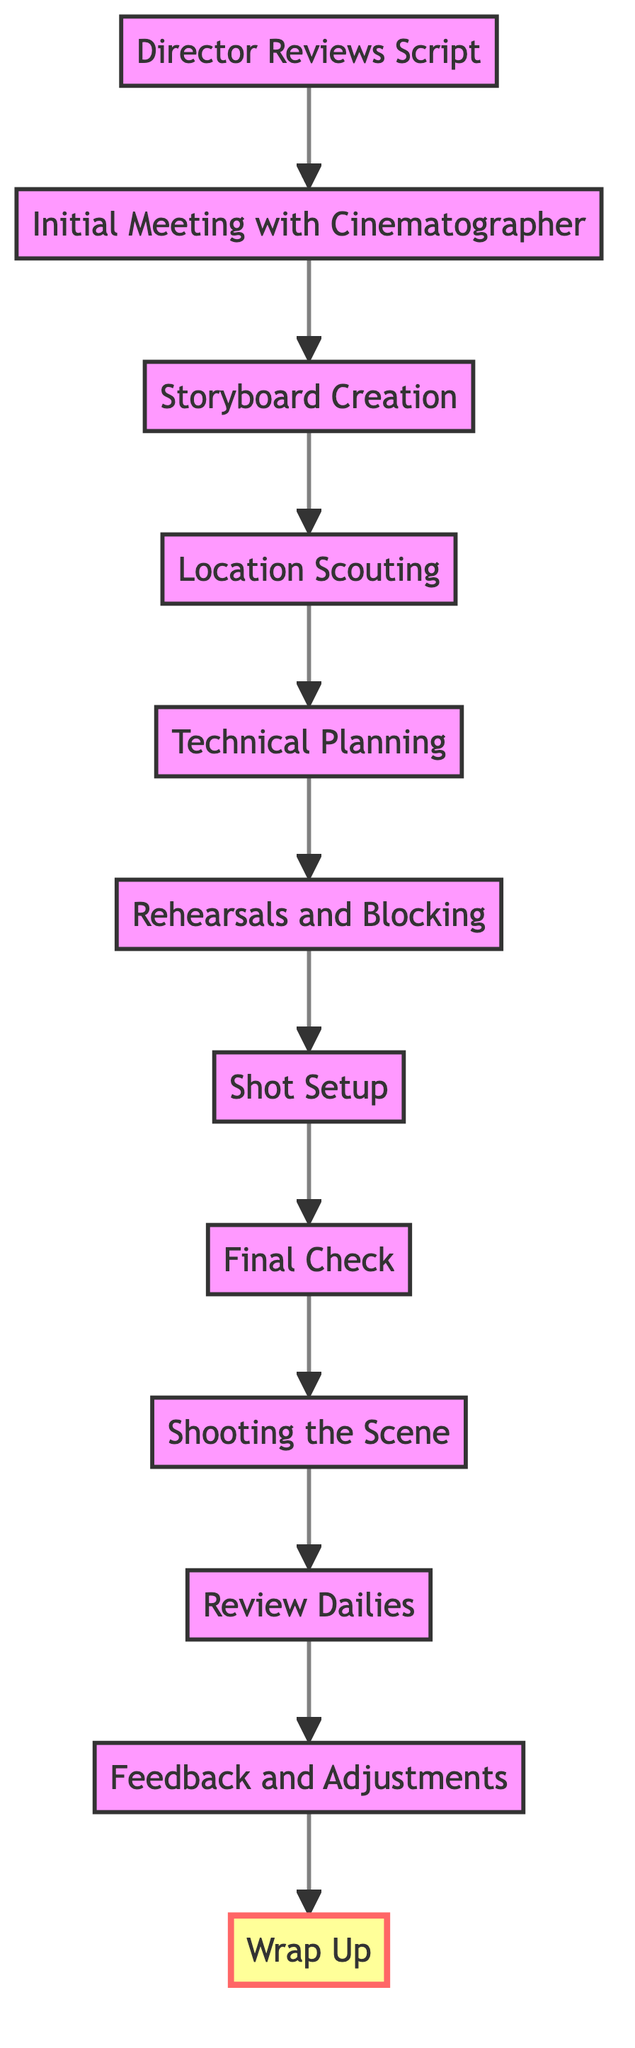What is the first step in the workflow? The first step is "Director Reviews Script," which initiates the collaboration process.
Answer: Director Reviews Script How many nodes are there in the diagram? The diagram contains 12 nodes representing different steps in the collaboration workflow.
Answer: 12 What happens after the "Initial Meeting with Cinematographer"? After "Initial Meeting with Cinematographer," the next step is "Storyboard Creation."
Answer: Storyboard Creation Which node follows "Shooting the Scene"? The node that follows "Shooting the Scene" is "Review Dailies."
Answer: Review Dailies What is the last step in the collaboration workflow? The last step is "Wrap Up," which occurs after all scenes are shot.
Answer: Wrap Up What is the relationship between "Technical Planning" and "Rehearsals and Blocking"? "Technical Planning" precedes "Rehearsals and Blocking," indicating that technical aspects are addressed before rehearsal.
Answer: Technical Planning precedes Rehearsals and Blocking What step involves the director and cinematographer working with actors? The step involving the director and cinematographer working with actors is "Rehearsals and Blocking."
Answer: Rehearsals and Blocking How many edges connect the nodes in the diagram? There are 11 edges connecting the nodes, representing the flow from one step to the next.
Answer: 11 What is the focus during the "Director Reviews Script" phase? The focus during this phase is on visual style and shot composition as the director annotates the script.
Answer: Visual style and shot composition 